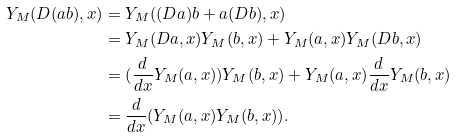Convert formula to latex. <formula><loc_0><loc_0><loc_500><loc_500>Y _ { M } ( D ( a b ) , x ) & = Y _ { M } ( ( D a ) b + a ( D b ) , x ) \\ & = Y _ { M } ( D a , x ) Y _ { M } ( b , x ) + Y _ { M } ( a , x ) Y _ { M } ( D b , x ) \\ & = ( \frac { d } { d x } Y _ { M } ( a , x ) ) Y _ { M } ( b , x ) + Y _ { M } ( a , x ) \frac { d } { d x } Y _ { M } ( b , x ) \\ & = \frac { d } { d x } ( Y _ { M } ( a , x ) Y _ { M } ( b , x ) ) .</formula> 